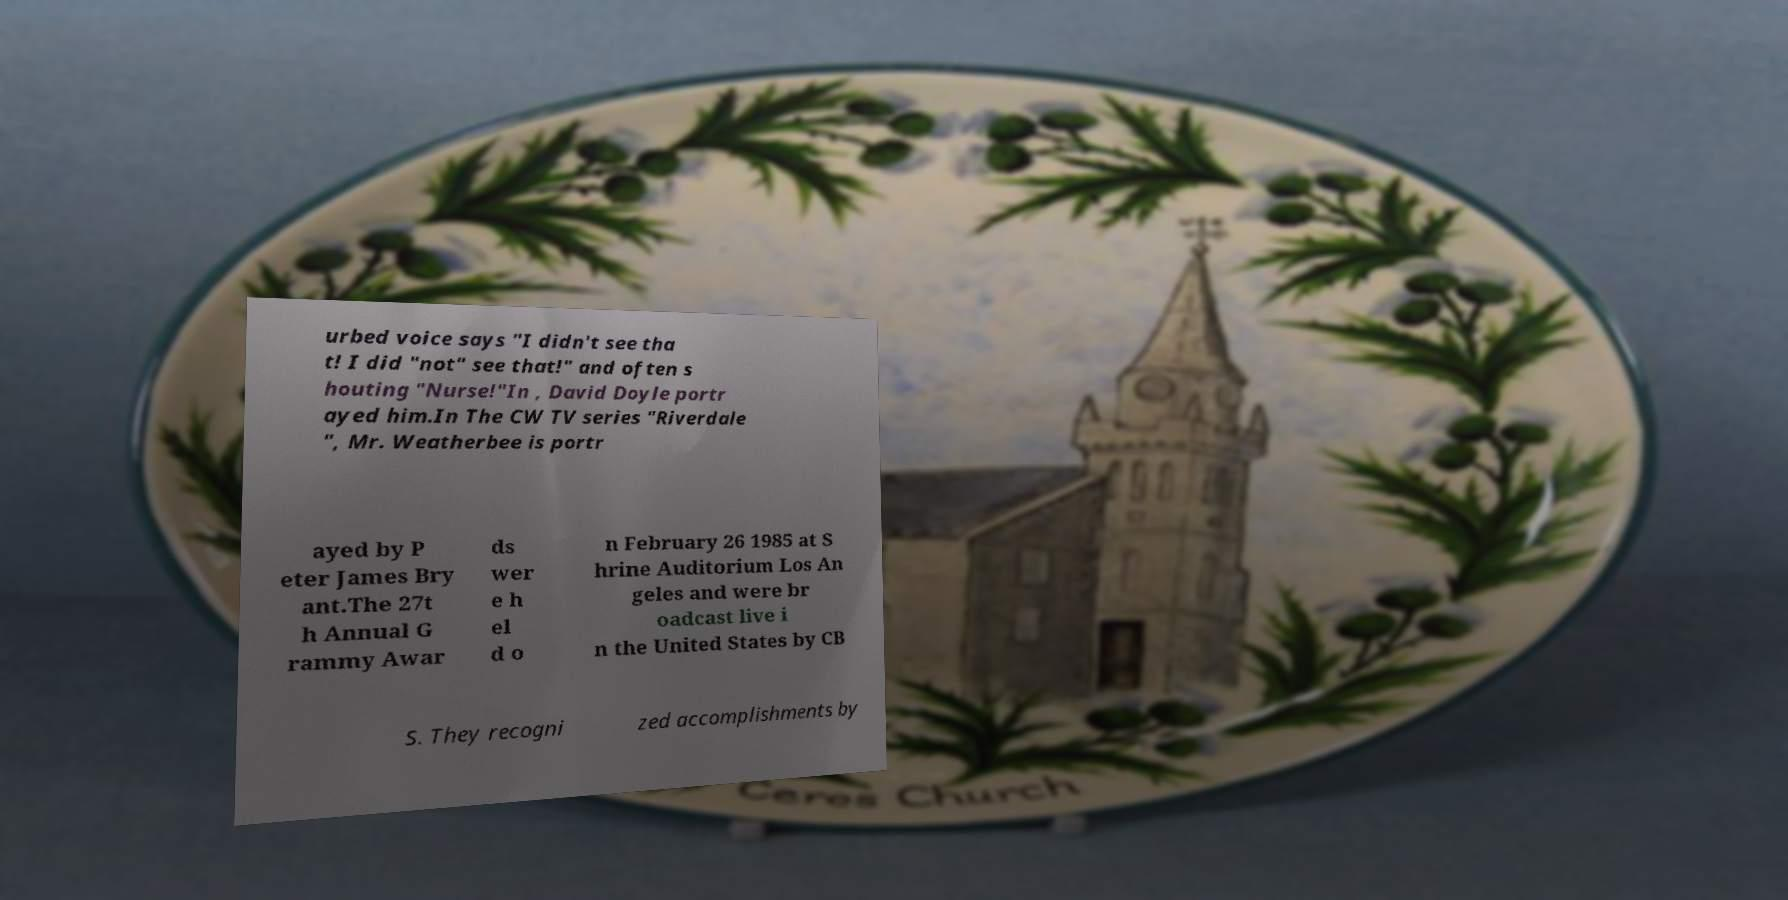Please read and relay the text visible in this image. What does it say? urbed voice says "I didn't see tha t! I did "not" see that!" and often s houting "Nurse!"In , David Doyle portr ayed him.In The CW TV series "Riverdale ", Mr. Weatherbee is portr ayed by P eter James Bry ant.The 27t h Annual G rammy Awar ds wer e h el d o n February 26 1985 at S hrine Auditorium Los An geles and were br oadcast live i n the United States by CB S. They recogni zed accomplishments by 